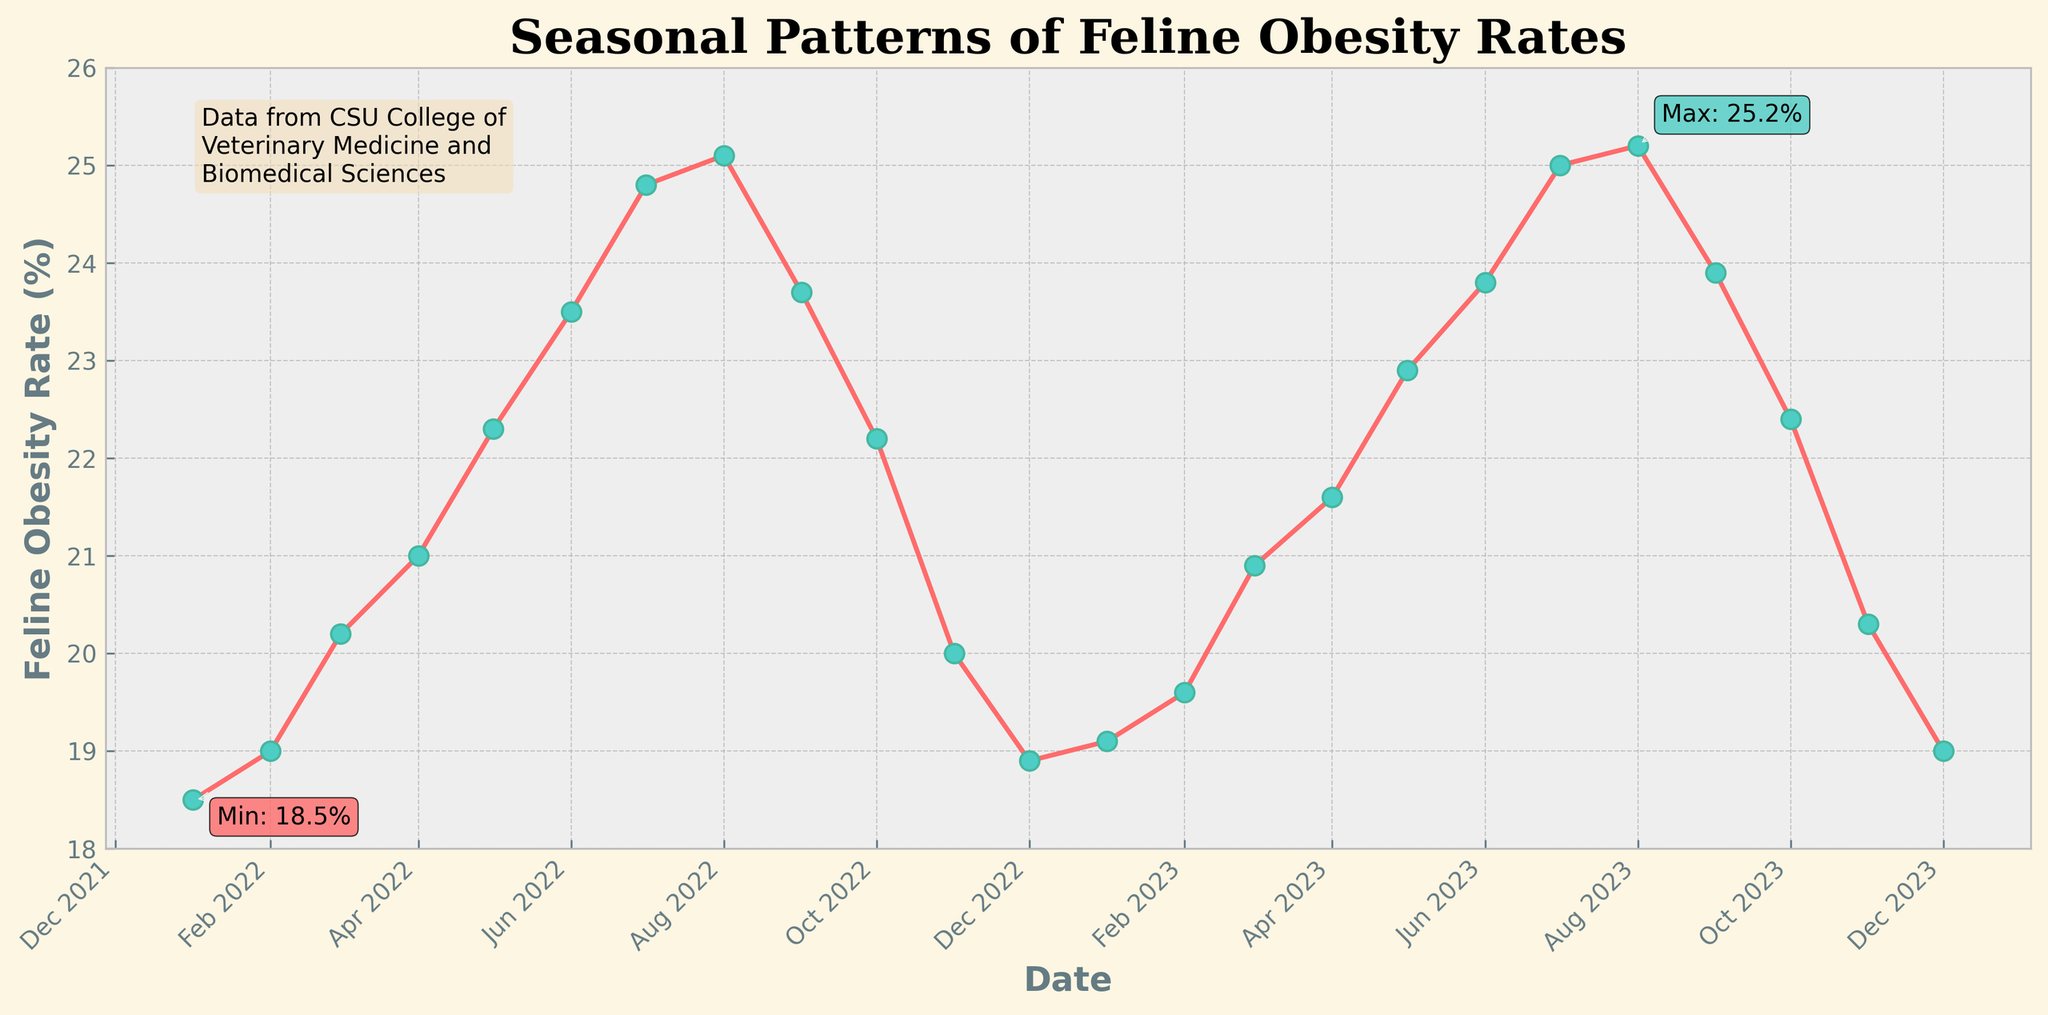What is the title of the figure? The title is prominently displayed at the top of the figure. It reads "Seasonal Patterns of Feline Obesity Rates".
Answer: Seasonal Patterns of Feline Obesity Rates What is the highest feline obesity rate observed in the figure, and when does it occur? The highest rate is annotated in the figure as 25.2%, and it occurs in August 2023.
Answer: 25.2%, August 2023 How does the feline obesity rate change from January 2022 to December 2022? The rate starts at 18.5% in January, gradually increases to peak at 25.1% in August, and then decreases to 18.9% by December.
Answer: Increases then decreases Which month shows the lowest obesity rate, and what is the value? The lowest obesity rate is annotated in the figure as 18.5%, and it occurs in January 2022.
Answer: 18.5%, January 2022 By how much does the obesity rate change from May 2022 to September 2022? The obesity rate in May 2022 is 22.3% and in September 2022 is 23.7%. The change is 23.7% - 22.3% = 1.4%.
Answer: 1.4% Which is higher: the obesity rate in February 2022 or February 2023? The obesity rate in February 2022 is 19.0%. In February 2023, it is 19.6%. Comparing these, February 2023's rate is higher.
Answer: February 2023 What trend can be observed in the feline obesity rate during the summer months (June to August) over the two years? During both years, the obesity rates in the summer months consistently increase, peaking in August.
Answer: Increases each summer How does the obesity rate in July 2022 compare to July 2023? The rate in July 2022 is 24.8%, while in July 2023 it is 25.0%. July 2023 has a slightly higher obesity rate.
Answer: July 2023 is higher What is the average obesity rate for the year 2022? To find the average for 2022, sum all monthly rates for 2022 and divide by 12: (18.5 + 19.0 + 20.2 + 21.0 + 22.3 + 23.5 + 24.8 + 25.1 + 23.7 + 22.2 + 20.0 + 18.9) / 12 = 22.04%.
Answer: 22.04% What seasonal pattern can be observed in the feline obesity rates from the plot? The rates generally increase from the beginning of the year, peak during the summer months, and decrease towards the end of the year, showing a cyclical seasonal pattern.
Answer: Increases, peaks in summer, then decreases 